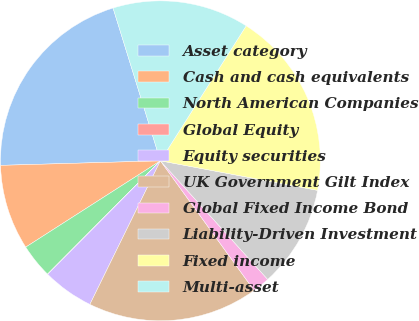Convert chart to OTSL. <chart><loc_0><loc_0><loc_500><loc_500><pie_chart><fcel>Asset category<fcel>Cash and cash equivalents<fcel>North American Companies<fcel>Global Equity<fcel>Equity securities<fcel>UK Government Gilt Index<fcel>Global Fixed Income Bond<fcel>Liability-Driven Investment<fcel>Fixed income<fcel>Multi-asset<nl><fcel>20.67%<fcel>8.62%<fcel>3.46%<fcel>0.02%<fcel>5.18%<fcel>17.23%<fcel>1.74%<fcel>10.34%<fcel>18.95%<fcel>13.79%<nl></chart> 